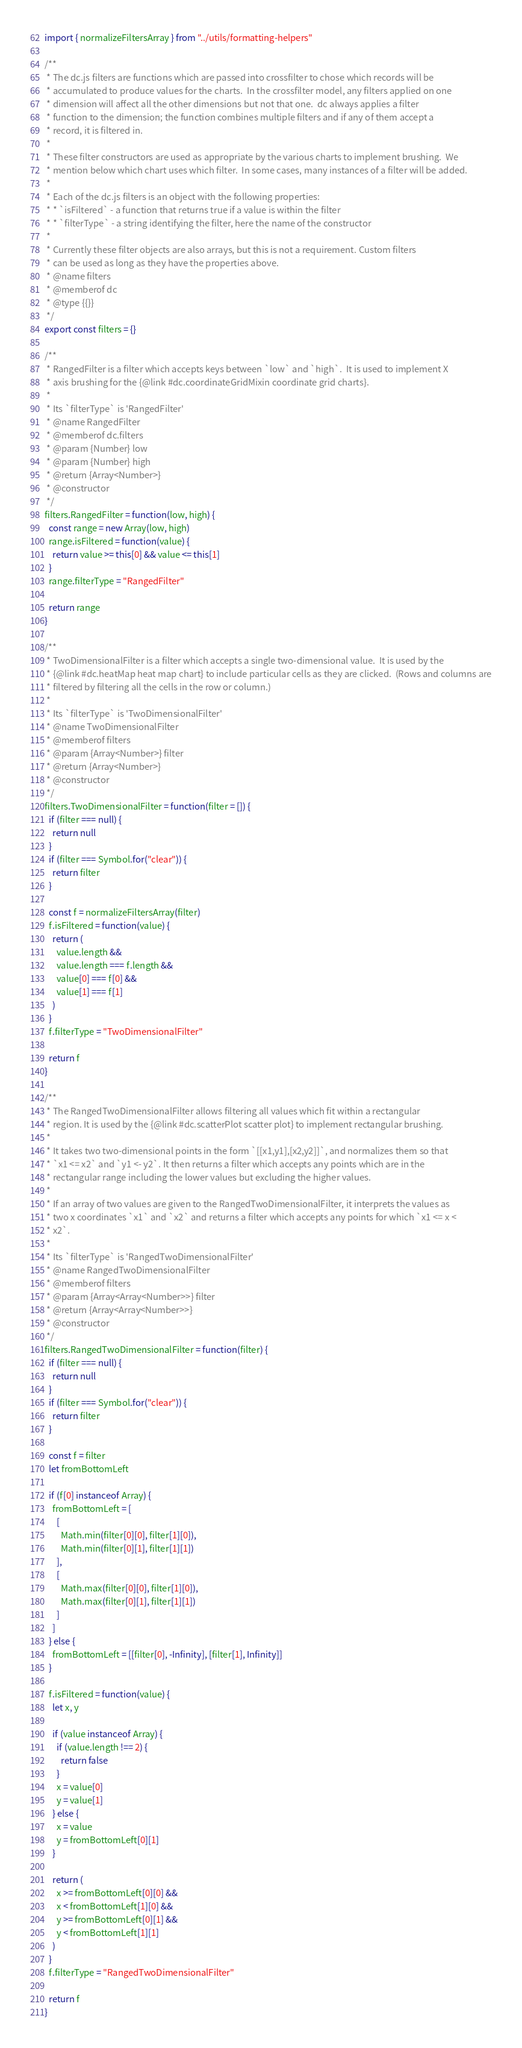<code> <loc_0><loc_0><loc_500><loc_500><_JavaScript_>import { normalizeFiltersArray } from "../utils/formatting-helpers"

/**
 * The dc.js filters are functions which are passed into crossfilter to chose which records will be
 * accumulated to produce values for the charts.  In the crossfilter model, any filters applied on one
 * dimension will affect all the other dimensions but not that one.  dc always applies a filter
 * function to the dimension; the function combines multiple filters and if any of them accept a
 * record, it is filtered in.
 *
 * These filter constructors are used as appropriate by the various charts to implement brushing.  We
 * mention below which chart uses which filter.  In some cases, many instances of a filter will be added.
 *
 * Each of the dc.js filters is an object with the following properties:
 * * `isFiltered` - a function that returns true if a value is within the filter
 * * `filterType` - a string identifying the filter, here the name of the constructor
 *
 * Currently these filter objects are also arrays, but this is not a requirement. Custom filters
 * can be used as long as they have the properties above.
 * @name filters
 * @memberof dc
 * @type {{}}
 */
export const filters = {}

/**
 * RangedFilter is a filter which accepts keys between `low` and `high`.  It is used to implement X
 * axis brushing for the {@link #dc.coordinateGridMixin coordinate grid charts}.
 *
 * Its `filterType` is 'RangedFilter'
 * @name RangedFilter
 * @memberof dc.filters
 * @param {Number} low
 * @param {Number} high
 * @return {Array<Number>}
 * @constructor
 */
filters.RangedFilter = function(low, high) {
  const range = new Array(low, high)
  range.isFiltered = function(value) {
    return value >= this[0] && value <= this[1]
  }
  range.filterType = "RangedFilter"

  return range
}

/**
 * TwoDimensionalFilter is a filter which accepts a single two-dimensional value.  It is used by the
 * {@link #dc.heatMap heat map chart} to include particular cells as they are clicked.  (Rows and columns are
 * filtered by filtering all the cells in the row or column.)
 *
 * Its `filterType` is 'TwoDimensionalFilter'
 * @name TwoDimensionalFilter
 * @memberof filters
 * @param {Array<Number>} filter
 * @return {Array<Number>}
 * @constructor
 */
filters.TwoDimensionalFilter = function(filter = []) {
  if (filter === null) {
    return null
  }
  if (filter === Symbol.for("clear")) {
    return filter
  }

  const f = normalizeFiltersArray(filter)
  f.isFiltered = function(value) {
    return (
      value.length &&
      value.length === f.length &&
      value[0] === f[0] &&
      value[1] === f[1]
    )
  }
  f.filterType = "TwoDimensionalFilter"

  return f
}

/**
 * The RangedTwoDimensionalFilter allows filtering all values which fit within a rectangular
 * region. It is used by the {@link #dc.scatterPlot scatter plot} to implement rectangular brushing.
 *
 * It takes two two-dimensional points in the form `[[x1,y1],[x2,y2]]`, and normalizes them so that
 * `x1 <= x2` and `y1 <- y2`. It then returns a filter which accepts any points which are in the
 * rectangular range including the lower values but excluding the higher values.
 *
 * If an array of two values are given to the RangedTwoDimensionalFilter, it interprets the values as
 * two x coordinates `x1` and `x2` and returns a filter which accepts any points for which `x1 <= x <
 * x2`.
 *
 * Its `filterType` is 'RangedTwoDimensionalFilter'
 * @name RangedTwoDimensionalFilter
 * @memberof filters
 * @param {Array<Array<Number>>} filter
 * @return {Array<Array<Number>>}
 * @constructor
 */
filters.RangedTwoDimensionalFilter = function(filter) {
  if (filter === null) {
    return null
  }
  if (filter === Symbol.for("clear")) {
    return filter
  }

  const f = filter
  let fromBottomLeft

  if (f[0] instanceof Array) {
    fromBottomLeft = [
      [
        Math.min(filter[0][0], filter[1][0]),
        Math.min(filter[0][1], filter[1][1])
      ],
      [
        Math.max(filter[0][0], filter[1][0]),
        Math.max(filter[0][1], filter[1][1])
      ]
    ]
  } else {
    fromBottomLeft = [[filter[0], -Infinity], [filter[1], Infinity]]
  }

  f.isFiltered = function(value) {
    let x, y

    if (value instanceof Array) {
      if (value.length !== 2) {
        return false
      }
      x = value[0]
      y = value[1]
    } else {
      x = value
      y = fromBottomLeft[0][1]
    }

    return (
      x >= fromBottomLeft[0][0] &&
      x < fromBottomLeft[1][0] &&
      y >= fromBottomLeft[0][1] &&
      y < fromBottomLeft[1][1]
    )
  }
  f.filterType = "RangedTwoDimensionalFilter"

  return f
}
</code> 